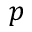<formula> <loc_0><loc_0><loc_500><loc_500>p</formula> 